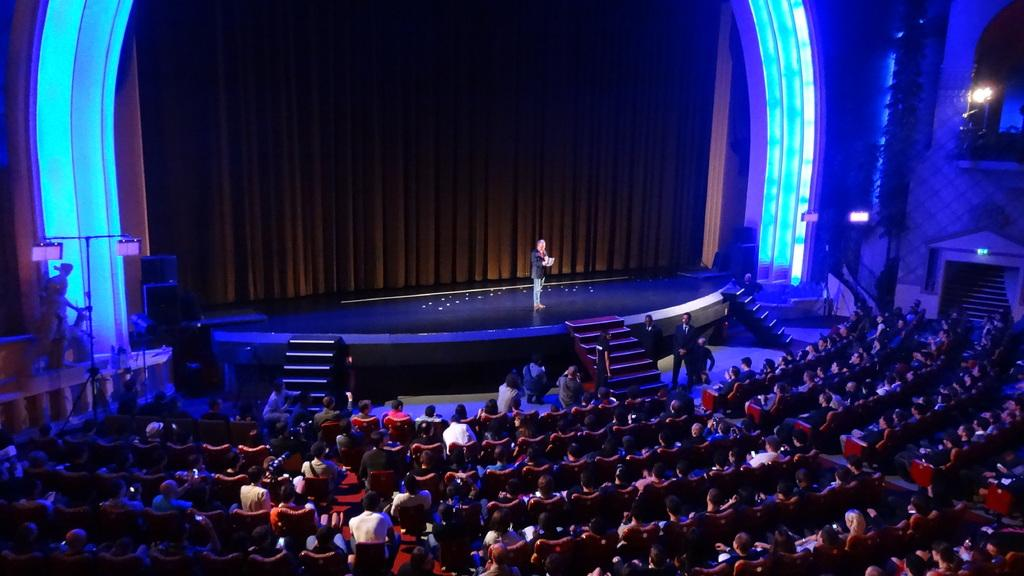What is the main feature of the image? There is a stage in the image. What are the people in the image doing? The people are sitting in chairs in the image. Can you describe any architectural features in the image? There are stairs in the image. What else can be seen in the image? There are lights in the image. Who is on the stage in the image? There is a person standing on the stage in the image. What type of stream can be seen flowing through the stage in the image? There is no stream present in the image; it features a stage with people sitting in chairs, stairs, and lights. 